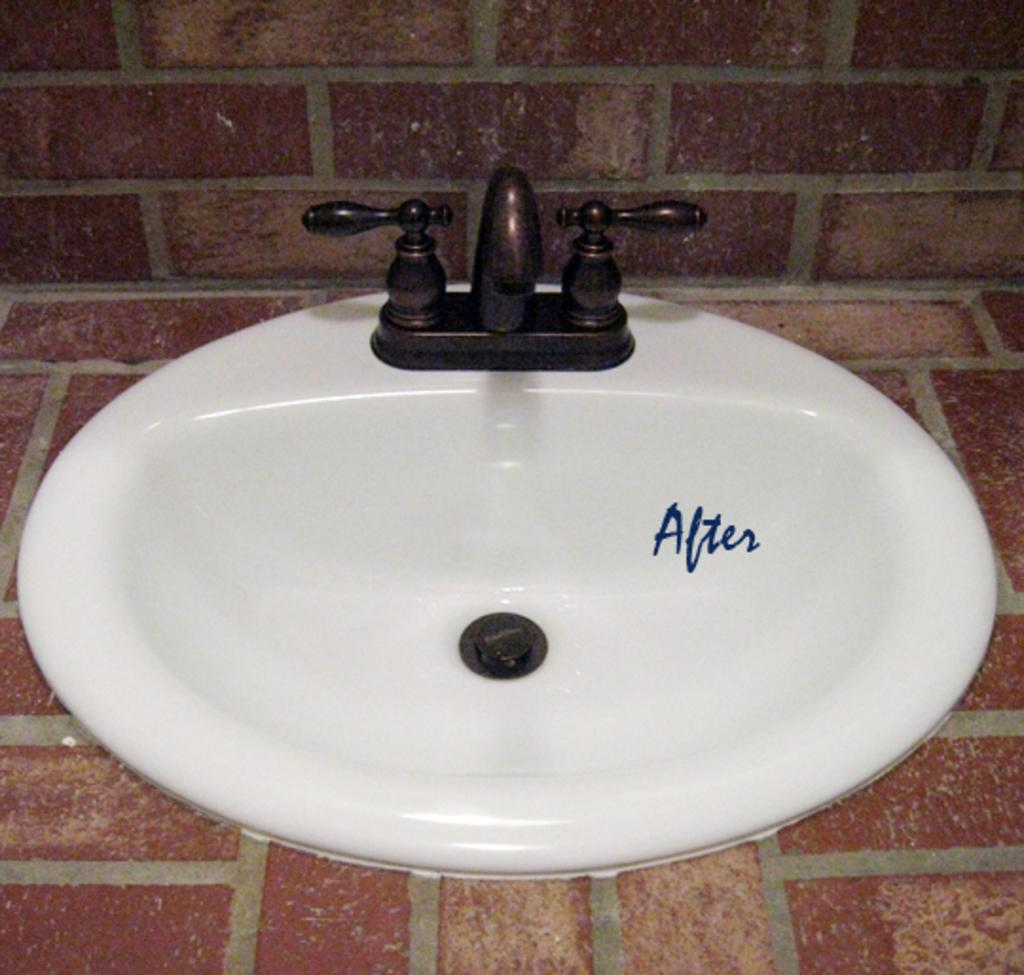What can be seen in the image that is used for washing or cleaning? There is a sink with a tap in the image. Where is the sink located? The sink is on a surface. What can be seen in the background of the image? There is a wall visible in the image. What type of disgust can be seen on the wall in the image? There is no indication of disgust on the wall in the image. 